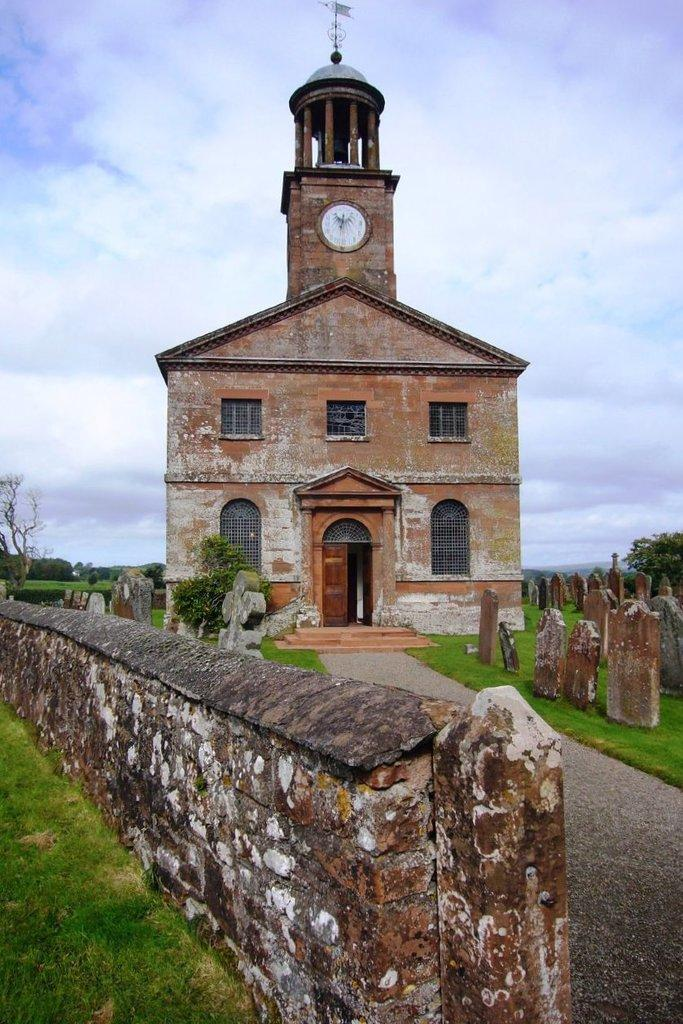What type of structure is featured in the image? There is a building with a clock tower in the image. Where is the clock tower located in relation to the building? The clock tower is above the building. What can be seen on the left side of the image? There is a wall on the left side of the image. What is present on either side of the wall? There is a garden on either side of the wall. What is visible above the wall? The sky is visible above the wall. What can be observed in the sky? Clouds are present in the sky. What is the person's desire for the pin in the image? There is no person or pin present in the image. 